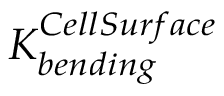Convert formula to latex. <formula><loc_0><loc_0><loc_500><loc_500>K _ { b e n d i n g } ^ { C e l l S u r f a c e }</formula> 